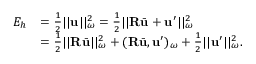Convert formula to latex. <formula><loc_0><loc_0><loc_500><loc_500>\begin{array} { r l } { E _ { h } } & { = \frac { 1 } { 2 } | | u | | _ { \omega } ^ { 2 } = \frac { 1 } { 2 } | | R \bar { u } + u ^ { \prime } | | _ { \omega } ^ { 2 } } \\ & { = \frac { 1 } { 2 } | | R \bar { u } | | _ { \omega } ^ { 2 } + ( R \bar { u } , u ^ { \prime } ) _ { \omega } + \frac { 1 } { 2 } | | u ^ { \prime } | | _ { \omega } ^ { 2 } . } \end{array}</formula> 